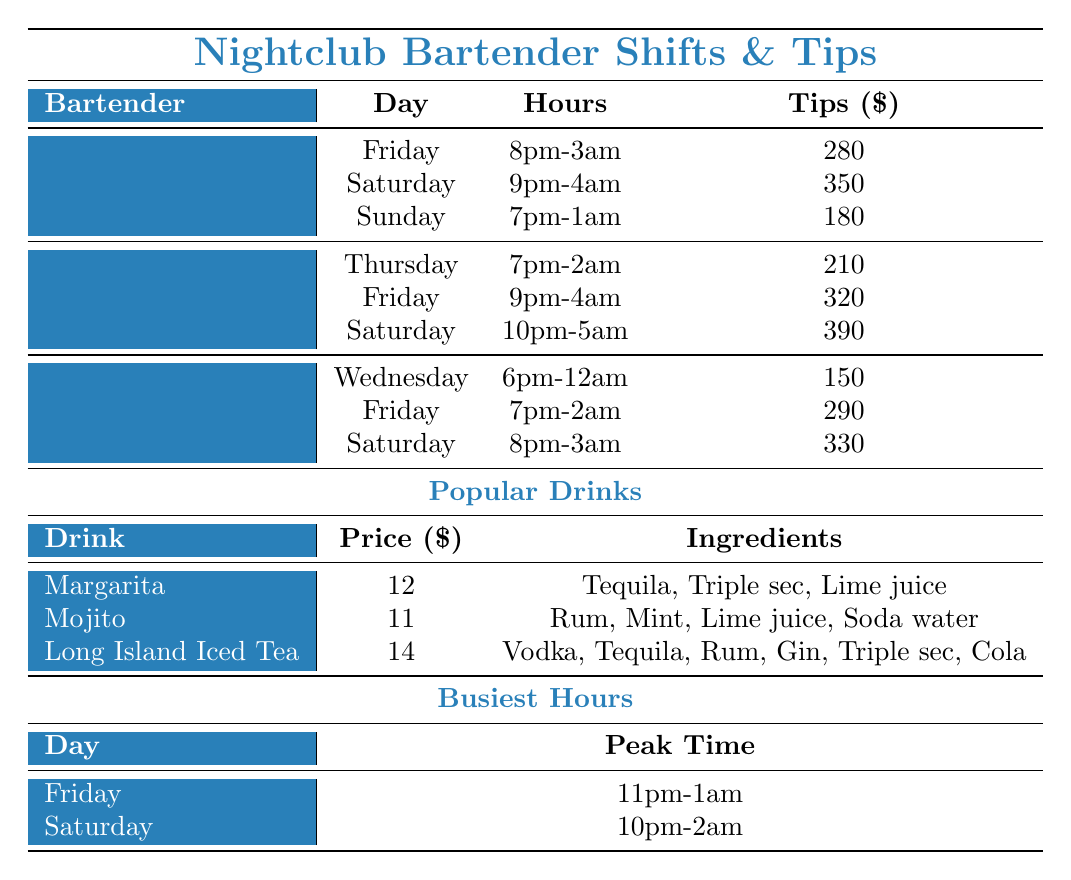What are the total tips earned by Jake during his shifts? Jake earned tips of 280 on Friday, 350 on Saturday, and 180 on Sunday. Adding these amounts gives us 280 + 350 + 180 = 810.
Answer: 810 On which day did Sarah earn the highest tips? Looking at Sarah's shifts, she earned 210 on Thursday, 320 on Friday, and 390 on Saturday. The highest amount is 390 on Saturday.
Answer: Saturday What is the average tips earned by Mike? Mike earned tips of 150 on Wednesday, 290 on Friday, and 330 on Saturday. The sum of his tips is 150 + 290 + 330 = 770. There are 3 shifts, so the average is 770 / 3 = 256.67.
Answer: 256.67 Which bartender worked the fewest hours? The shifts for each bartender need to be checked: Jake worked 7 hours total, Sarah worked 8 hours total, and Mike worked 8 hours total. Jake has the fewest hours at 7.
Answer: Jake Are there any bartenders who worked on Sunday? Jake was the only bartender to work on Sunday, where he earned 180 in tips.
Answer: Yes What is the total amount earned in tips by all bartenders on Friday? On Friday, Jake earned 280, Sarah earned 320, and Mike earned 290. Summing these gives 280 + 320 + 290 = 890.
Answer: 890 Which drink is the most expensive? The prices of the drinks are: Margarita for 12, Mojito for 11, and Long Island Iced Tea for 14. The highest price is 14 for the Long Island Iced Tea.
Answer: Long Island Iced Tea What is the peak time on Saturday? According to the busiest hours, the peak time on Saturday is 10pm-2am.
Answer: 10pm-2am How much did Sarah earn in tips across all her shifts? Sarah's shifts earned her tips of 210 on Thursday, 320 on Friday, and 390 on Saturday. Totaling these amounts gives 210 + 320 + 390 = 920.
Answer: 920 On which day does Mike have the highest earnings? Mike's tips on his shifts are 150 on Wednesday, 290 on Friday, and 330 on Saturday. The highest earning is 330 on Saturday.
Answer: Saturday 